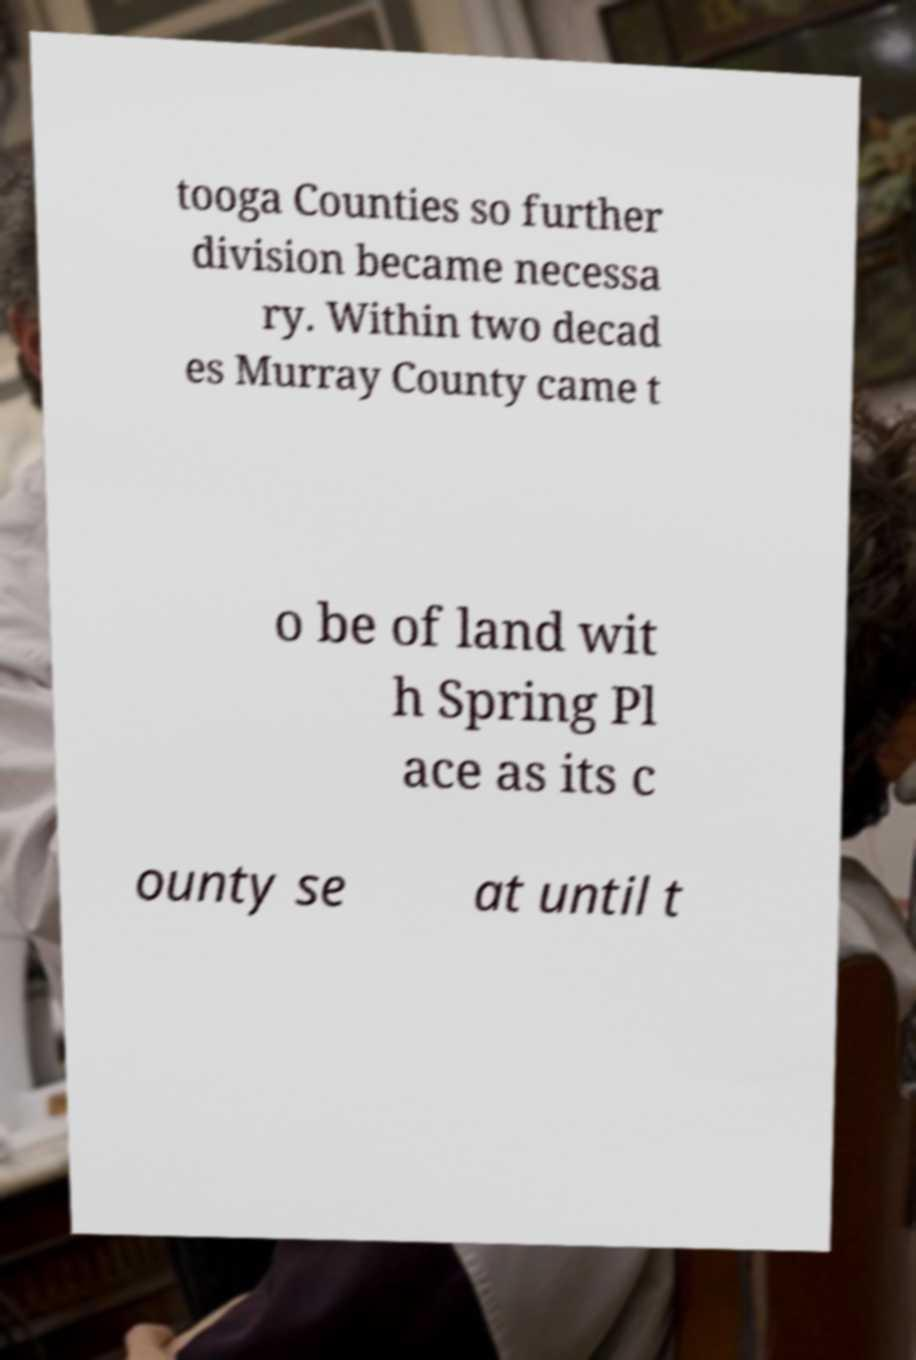Please read and relay the text visible in this image. What does it say? tooga Counties so further division became necessa ry. Within two decad es Murray County came t o be of land wit h Spring Pl ace as its c ounty se at until t 